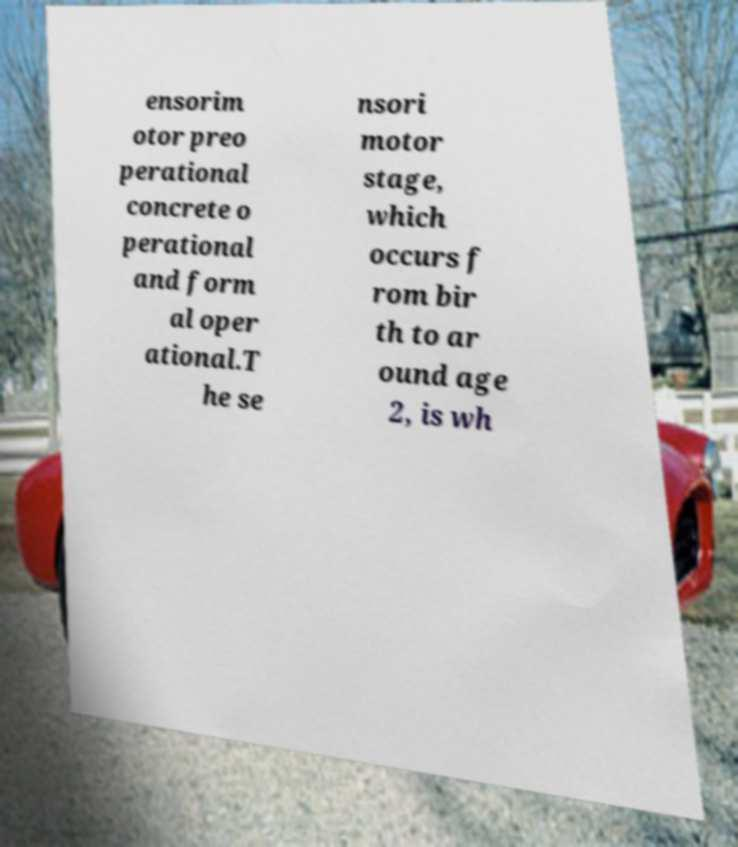For documentation purposes, I need the text within this image transcribed. Could you provide that? ensorim otor preo perational concrete o perational and form al oper ational.T he se nsori motor stage, which occurs f rom bir th to ar ound age 2, is wh 